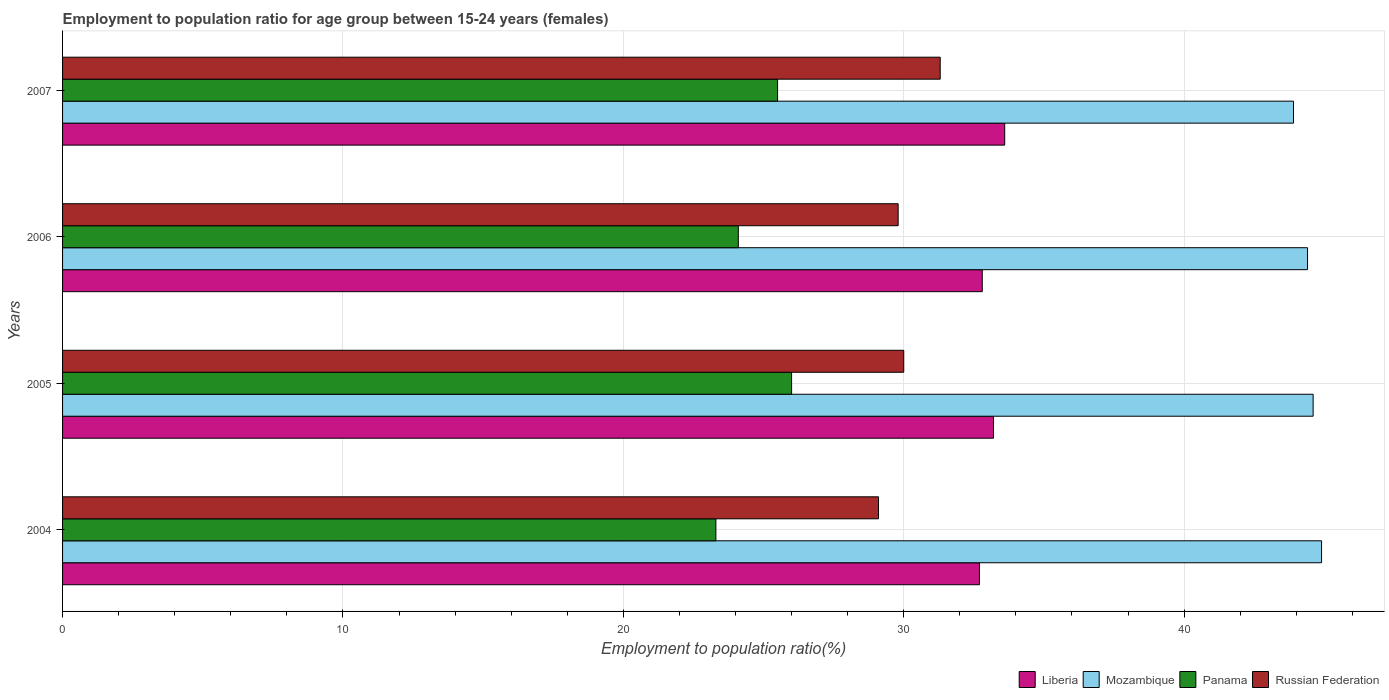How many different coloured bars are there?
Your response must be concise. 4. Are the number of bars on each tick of the Y-axis equal?
Offer a terse response. Yes. How many bars are there on the 1st tick from the bottom?
Offer a very short reply. 4. What is the label of the 3rd group of bars from the top?
Offer a very short reply. 2005. In how many cases, is the number of bars for a given year not equal to the number of legend labels?
Keep it short and to the point. 0. What is the employment to population ratio in Russian Federation in 2004?
Offer a terse response. 29.1. Across all years, what is the maximum employment to population ratio in Panama?
Offer a terse response. 26. Across all years, what is the minimum employment to population ratio in Mozambique?
Offer a terse response. 43.9. In which year was the employment to population ratio in Panama maximum?
Offer a terse response. 2005. In which year was the employment to population ratio in Russian Federation minimum?
Ensure brevity in your answer.  2004. What is the total employment to population ratio in Liberia in the graph?
Make the answer very short. 132.3. What is the difference between the employment to population ratio in Panama in 2004 and that in 2005?
Provide a succinct answer. -2.7. What is the difference between the employment to population ratio in Mozambique in 2004 and the employment to population ratio in Liberia in 2005?
Provide a short and direct response. 11.7. What is the average employment to population ratio in Panama per year?
Provide a short and direct response. 24.72. In the year 2005, what is the difference between the employment to population ratio in Liberia and employment to population ratio in Mozambique?
Offer a terse response. -11.4. In how many years, is the employment to population ratio in Mozambique greater than 6 %?
Ensure brevity in your answer.  4. What is the ratio of the employment to population ratio in Russian Federation in 2004 to that in 2007?
Make the answer very short. 0.93. Is the difference between the employment to population ratio in Liberia in 2005 and 2007 greater than the difference between the employment to population ratio in Mozambique in 2005 and 2007?
Offer a terse response. No. What is the difference between the highest and the second highest employment to population ratio in Mozambique?
Offer a very short reply. 0.3. In how many years, is the employment to population ratio in Russian Federation greater than the average employment to population ratio in Russian Federation taken over all years?
Give a very brief answer. 1. What does the 2nd bar from the top in 2007 represents?
Your response must be concise. Panama. What does the 2nd bar from the bottom in 2006 represents?
Make the answer very short. Mozambique. How many bars are there?
Offer a very short reply. 16. What is the difference between two consecutive major ticks on the X-axis?
Make the answer very short. 10. Does the graph contain grids?
Make the answer very short. Yes. How many legend labels are there?
Offer a very short reply. 4. How are the legend labels stacked?
Your response must be concise. Horizontal. What is the title of the graph?
Keep it short and to the point. Employment to population ratio for age group between 15-24 years (females). What is the Employment to population ratio(%) in Liberia in 2004?
Provide a short and direct response. 32.7. What is the Employment to population ratio(%) in Mozambique in 2004?
Your response must be concise. 44.9. What is the Employment to population ratio(%) of Panama in 2004?
Give a very brief answer. 23.3. What is the Employment to population ratio(%) of Russian Federation in 2004?
Keep it short and to the point. 29.1. What is the Employment to population ratio(%) in Liberia in 2005?
Ensure brevity in your answer.  33.2. What is the Employment to population ratio(%) in Mozambique in 2005?
Keep it short and to the point. 44.6. What is the Employment to population ratio(%) of Panama in 2005?
Make the answer very short. 26. What is the Employment to population ratio(%) of Russian Federation in 2005?
Offer a very short reply. 30. What is the Employment to population ratio(%) in Liberia in 2006?
Provide a succinct answer. 32.8. What is the Employment to population ratio(%) in Mozambique in 2006?
Provide a succinct answer. 44.4. What is the Employment to population ratio(%) in Panama in 2006?
Make the answer very short. 24.1. What is the Employment to population ratio(%) in Russian Federation in 2006?
Provide a succinct answer. 29.8. What is the Employment to population ratio(%) of Liberia in 2007?
Your answer should be compact. 33.6. What is the Employment to population ratio(%) in Mozambique in 2007?
Provide a succinct answer. 43.9. What is the Employment to population ratio(%) of Russian Federation in 2007?
Give a very brief answer. 31.3. Across all years, what is the maximum Employment to population ratio(%) of Liberia?
Your answer should be compact. 33.6. Across all years, what is the maximum Employment to population ratio(%) in Mozambique?
Make the answer very short. 44.9. Across all years, what is the maximum Employment to population ratio(%) in Russian Federation?
Make the answer very short. 31.3. Across all years, what is the minimum Employment to population ratio(%) of Liberia?
Ensure brevity in your answer.  32.7. Across all years, what is the minimum Employment to population ratio(%) in Mozambique?
Provide a succinct answer. 43.9. Across all years, what is the minimum Employment to population ratio(%) in Panama?
Give a very brief answer. 23.3. Across all years, what is the minimum Employment to population ratio(%) in Russian Federation?
Keep it short and to the point. 29.1. What is the total Employment to population ratio(%) in Liberia in the graph?
Provide a short and direct response. 132.3. What is the total Employment to population ratio(%) of Mozambique in the graph?
Your response must be concise. 177.8. What is the total Employment to population ratio(%) of Panama in the graph?
Offer a terse response. 98.9. What is the total Employment to population ratio(%) in Russian Federation in the graph?
Ensure brevity in your answer.  120.2. What is the difference between the Employment to population ratio(%) of Panama in 2004 and that in 2005?
Give a very brief answer. -2.7. What is the difference between the Employment to population ratio(%) in Russian Federation in 2004 and that in 2005?
Provide a succinct answer. -0.9. What is the difference between the Employment to population ratio(%) in Panama in 2004 and that in 2006?
Give a very brief answer. -0.8. What is the difference between the Employment to population ratio(%) in Russian Federation in 2004 and that in 2006?
Provide a short and direct response. -0.7. What is the difference between the Employment to population ratio(%) of Liberia in 2005 and that in 2006?
Your answer should be compact. 0.4. What is the difference between the Employment to population ratio(%) in Mozambique in 2005 and that in 2006?
Your response must be concise. 0.2. What is the difference between the Employment to population ratio(%) of Panama in 2005 and that in 2006?
Ensure brevity in your answer.  1.9. What is the difference between the Employment to population ratio(%) of Russian Federation in 2005 and that in 2006?
Offer a very short reply. 0.2. What is the difference between the Employment to population ratio(%) in Liberia in 2005 and that in 2007?
Make the answer very short. -0.4. What is the difference between the Employment to population ratio(%) of Mozambique in 2005 and that in 2007?
Ensure brevity in your answer.  0.7. What is the difference between the Employment to population ratio(%) of Russian Federation in 2005 and that in 2007?
Keep it short and to the point. -1.3. What is the difference between the Employment to population ratio(%) of Liberia in 2006 and that in 2007?
Your answer should be very brief. -0.8. What is the difference between the Employment to population ratio(%) of Russian Federation in 2006 and that in 2007?
Give a very brief answer. -1.5. What is the difference between the Employment to population ratio(%) of Liberia in 2004 and the Employment to population ratio(%) of Panama in 2005?
Your answer should be compact. 6.7. What is the difference between the Employment to population ratio(%) of Liberia in 2004 and the Employment to population ratio(%) of Russian Federation in 2005?
Make the answer very short. 2.7. What is the difference between the Employment to population ratio(%) in Mozambique in 2004 and the Employment to population ratio(%) in Panama in 2005?
Provide a short and direct response. 18.9. What is the difference between the Employment to population ratio(%) of Mozambique in 2004 and the Employment to population ratio(%) of Russian Federation in 2005?
Provide a short and direct response. 14.9. What is the difference between the Employment to population ratio(%) of Panama in 2004 and the Employment to population ratio(%) of Russian Federation in 2005?
Make the answer very short. -6.7. What is the difference between the Employment to population ratio(%) of Liberia in 2004 and the Employment to population ratio(%) of Mozambique in 2006?
Give a very brief answer. -11.7. What is the difference between the Employment to population ratio(%) in Liberia in 2004 and the Employment to population ratio(%) in Panama in 2006?
Offer a very short reply. 8.6. What is the difference between the Employment to population ratio(%) in Mozambique in 2004 and the Employment to population ratio(%) in Panama in 2006?
Provide a succinct answer. 20.8. What is the difference between the Employment to population ratio(%) of Mozambique in 2004 and the Employment to population ratio(%) of Russian Federation in 2006?
Offer a terse response. 15.1. What is the difference between the Employment to population ratio(%) in Panama in 2004 and the Employment to population ratio(%) in Russian Federation in 2006?
Make the answer very short. -6.5. What is the difference between the Employment to population ratio(%) of Liberia in 2004 and the Employment to population ratio(%) of Mozambique in 2007?
Your answer should be very brief. -11.2. What is the difference between the Employment to population ratio(%) of Panama in 2004 and the Employment to population ratio(%) of Russian Federation in 2007?
Offer a terse response. -8. What is the difference between the Employment to population ratio(%) in Liberia in 2005 and the Employment to population ratio(%) in Mozambique in 2007?
Your answer should be compact. -10.7. What is the difference between the Employment to population ratio(%) of Liberia in 2005 and the Employment to population ratio(%) of Panama in 2007?
Keep it short and to the point. 7.7. What is the difference between the Employment to population ratio(%) in Panama in 2005 and the Employment to population ratio(%) in Russian Federation in 2007?
Keep it short and to the point. -5.3. What is the difference between the Employment to population ratio(%) of Liberia in 2006 and the Employment to population ratio(%) of Russian Federation in 2007?
Your answer should be compact. 1.5. What is the average Employment to population ratio(%) in Liberia per year?
Make the answer very short. 33.08. What is the average Employment to population ratio(%) in Mozambique per year?
Your answer should be compact. 44.45. What is the average Employment to population ratio(%) in Panama per year?
Give a very brief answer. 24.73. What is the average Employment to population ratio(%) in Russian Federation per year?
Your answer should be compact. 30.05. In the year 2004, what is the difference between the Employment to population ratio(%) in Liberia and Employment to population ratio(%) in Mozambique?
Keep it short and to the point. -12.2. In the year 2004, what is the difference between the Employment to population ratio(%) in Liberia and Employment to population ratio(%) in Panama?
Provide a succinct answer. 9.4. In the year 2004, what is the difference between the Employment to population ratio(%) in Liberia and Employment to population ratio(%) in Russian Federation?
Offer a terse response. 3.6. In the year 2004, what is the difference between the Employment to population ratio(%) of Mozambique and Employment to population ratio(%) of Panama?
Offer a very short reply. 21.6. In the year 2004, what is the difference between the Employment to population ratio(%) of Mozambique and Employment to population ratio(%) of Russian Federation?
Provide a short and direct response. 15.8. In the year 2005, what is the difference between the Employment to population ratio(%) in Liberia and Employment to population ratio(%) in Mozambique?
Keep it short and to the point. -11.4. In the year 2005, what is the difference between the Employment to population ratio(%) of Mozambique and Employment to population ratio(%) of Panama?
Ensure brevity in your answer.  18.6. In the year 2005, what is the difference between the Employment to population ratio(%) of Panama and Employment to population ratio(%) of Russian Federation?
Offer a very short reply. -4. In the year 2006, what is the difference between the Employment to population ratio(%) in Liberia and Employment to population ratio(%) in Russian Federation?
Make the answer very short. 3. In the year 2006, what is the difference between the Employment to population ratio(%) of Mozambique and Employment to population ratio(%) of Panama?
Provide a succinct answer. 20.3. In the year 2007, what is the difference between the Employment to population ratio(%) of Liberia and Employment to population ratio(%) of Mozambique?
Offer a very short reply. -10.3. In the year 2007, what is the difference between the Employment to population ratio(%) of Liberia and Employment to population ratio(%) of Panama?
Your answer should be compact. 8.1. In the year 2007, what is the difference between the Employment to population ratio(%) in Liberia and Employment to population ratio(%) in Russian Federation?
Offer a terse response. 2.3. In the year 2007, what is the difference between the Employment to population ratio(%) in Mozambique and Employment to population ratio(%) in Panama?
Offer a very short reply. 18.4. In the year 2007, what is the difference between the Employment to population ratio(%) of Mozambique and Employment to population ratio(%) of Russian Federation?
Your answer should be very brief. 12.6. In the year 2007, what is the difference between the Employment to population ratio(%) of Panama and Employment to population ratio(%) of Russian Federation?
Offer a very short reply. -5.8. What is the ratio of the Employment to population ratio(%) of Liberia in 2004 to that in 2005?
Keep it short and to the point. 0.98. What is the ratio of the Employment to population ratio(%) of Panama in 2004 to that in 2005?
Your answer should be very brief. 0.9. What is the ratio of the Employment to population ratio(%) of Russian Federation in 2004 to that in 2005?
Your answer should be very brief. 0.97. What is the ratio of the Employment to population ratio(%) in Liberia in 2004 to that in 2006?
Offer a terse response. 1. What is the ratio of the Employment to population ratio(%) of Mozambique in 2004 to that in 2006?
Give a very brief answer. 1.01. What is the ratio of the Employment to population ratio(%) of Panama in 2004 to that in 2006?
Your response must be concise. 0.97. What is the ratio of the Employment to population ratio(%) in Russian Federation in 2004 to that in 2006?
Ensure brevity in your answer.  0.98. What is the ratio of the Employment to population ratio(%) in Liberia in 2004 to that in 2007?
Ensure brevity in your answer.  0.97. What is the ratio of the Employment to population ratio(%) of Mozambique in 2004 to that in 2007?
Keep it short and to the point. 1.02. What is the ratio of the Employment to population ratio(%) of Panama in 2004 to that in 2007?
Your response must be concise. 0.91. What is the ratio of the Employment to population ratio(%) of Russian Federation in 2004 to that in 2007?
Provide a succinct answer. 0.93. What is the ratio of the Employment to population ratio(%) in Liberia in 2005 to that in 2006?
Offer a very short reply. 1.01. What is the ratio of the Employment to population ratio(%) in Mozambique in 2005 to that in 2006?
Give a very brief answer. 1. What is the ratio of the Employment to population ratio(%) of Panama in 2005 to that in 2006?
Provide a succinct answer. 1.08. What is the ratio of the Employment to population ratio(%) of Liberia in 2005 to that in 2007?
Ensure brevity in your answer.  0.99. What is the ratio of the Employment to population ratio(%) of Mozambique in 2005 to that in 2007?
Offer a terse response. 1.02. What is the ratio of the Employment to population ratio(%) in Panama in 2005 to that in 2007?
Offer a terse response. 1.02. What is the ratio of the Employment to population ratio(%) in Russian Federation in 2005 to that in 2007?
Your answer should be compact. 0.96. What is the ratio of the Employment to population ratio(%) in Liberia in 2006 to that in 2007?
Ensure brevity in your answer.  0.98. What is the ratio of the Employment to population ratio(%) of Mozambique in 2006 to that in 2007?
Keep it short and to the point. 1.01. What is the ratio of the Employment to population ratio(%) of Panama in 2006 to that in 2007?
Make the answer very short. 0.95. What is the ratio of the Employment to population ratio(%) of Russian Federation in 2006 to that in 2007?
Provide a short and direct response. 0.95. What is the difference between the highest and the second highest Employment to population ratio(%) in Mozambique?
Give a very brief answer. 0.3. What is the difference between the highest and the second highest Employment to population ratio(%) in Panama?
Your answer should be very brief. 0.5. What is the difference between the highest and the second highest Employment to population ratio(%) of Russian Federation?
Keep it short and to the point. 1.3. What is the difference between the highest and the lowest Employment to population ratio(%) of Liberia?
Your answer should be very brief. 0.9. What is the difference between the highest and the lowest Employment to population ratio(%) in Panama?
Your answer should be very brief. 2.7. What is the difference between the highest and the lowest Employment to population ratio(%) in Russian Federation?
Give a very brief answer. 2.2. 